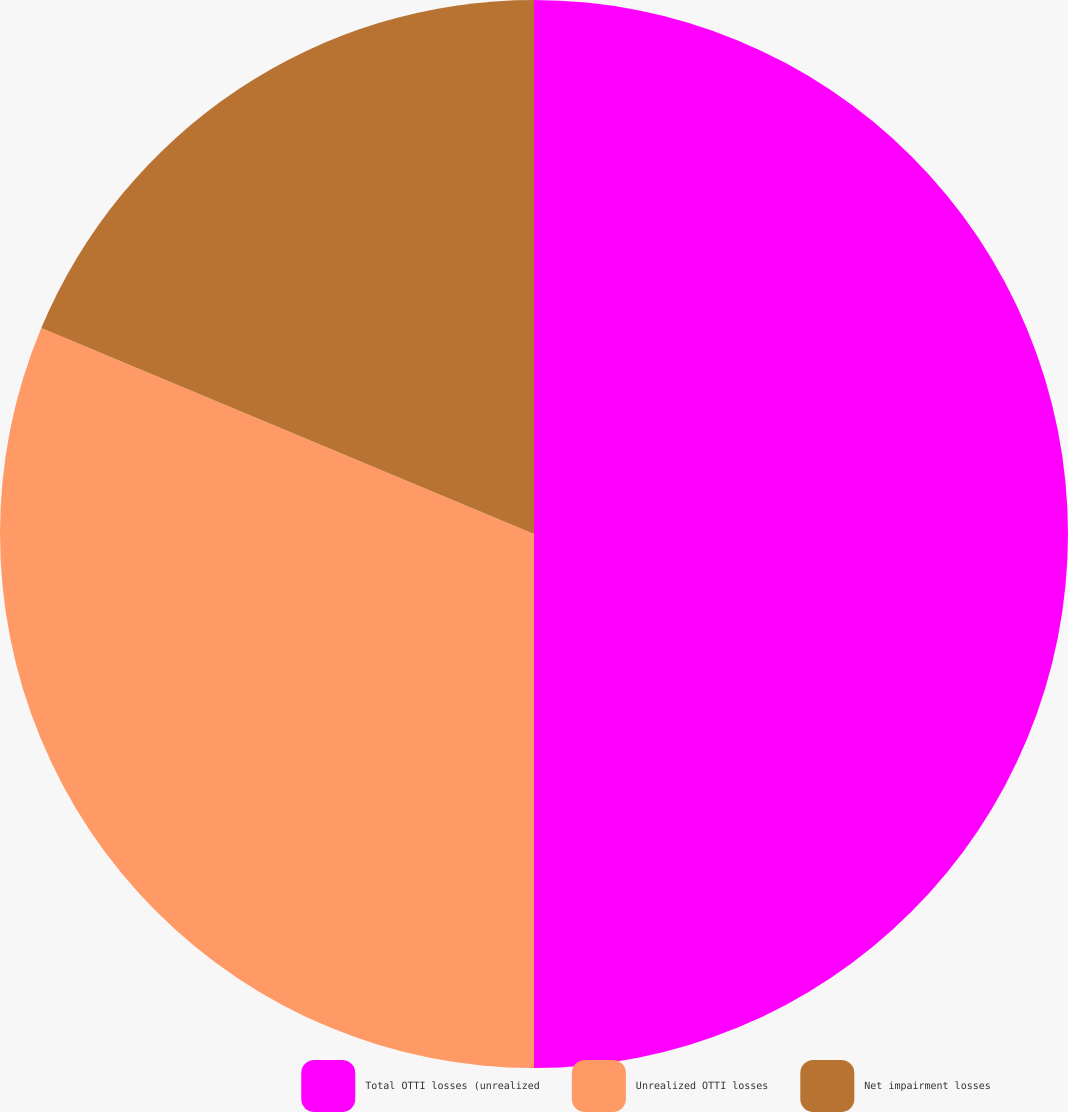Convert chart. <chart><loc_0><loc_0><loc_500><loc_500><pie_chart><fcel>Total OTTI losses (unrealized<fcel>Unrealized OTTI losses<fcel>Net impairment losses<nl><fcel>50.0%<fcel>31.3%<fcel>18.7%<nl></chart> 